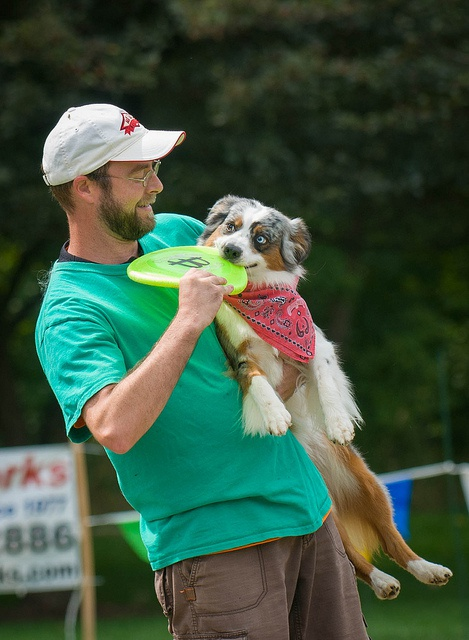Describe the objects in this image and their specific colors. I can see people in black, teal, and gray tones, dog in black, darkgray, lightgray, olive, and tan tones, and frisbee in black, lightgreen, and beige tones in this image. 